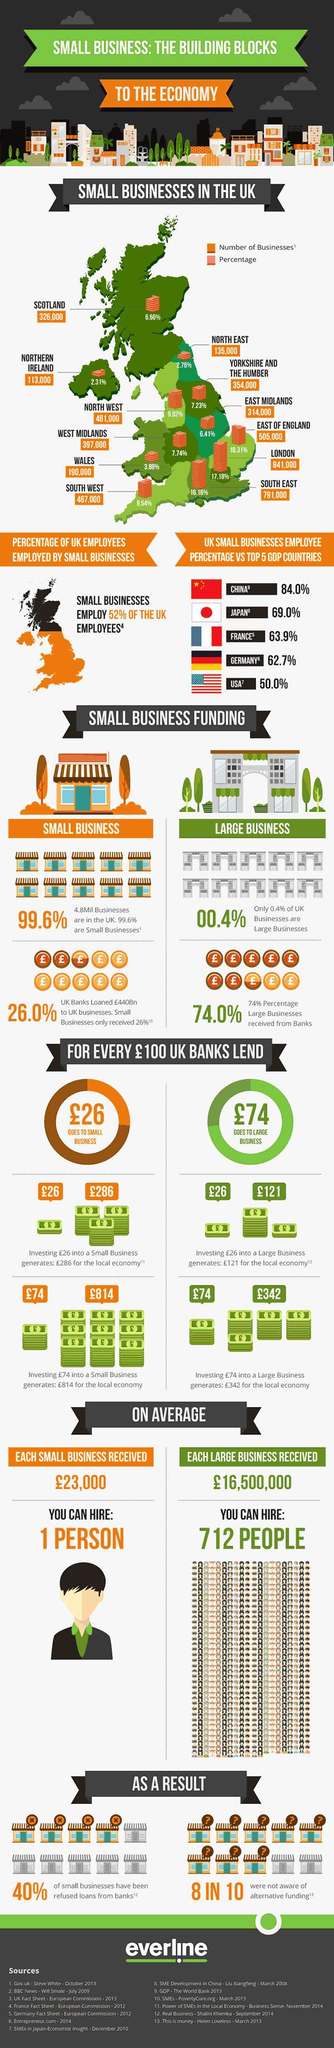Indicate a few pertinent items in this graphic. According to the data, Northern Ireland has the lowest percentage of small businesses out of all the areas listed. London has the highest number of businesses among all areas. According to the survey, approximately 2 out of 10 businesses were aware of alternative funding options. 